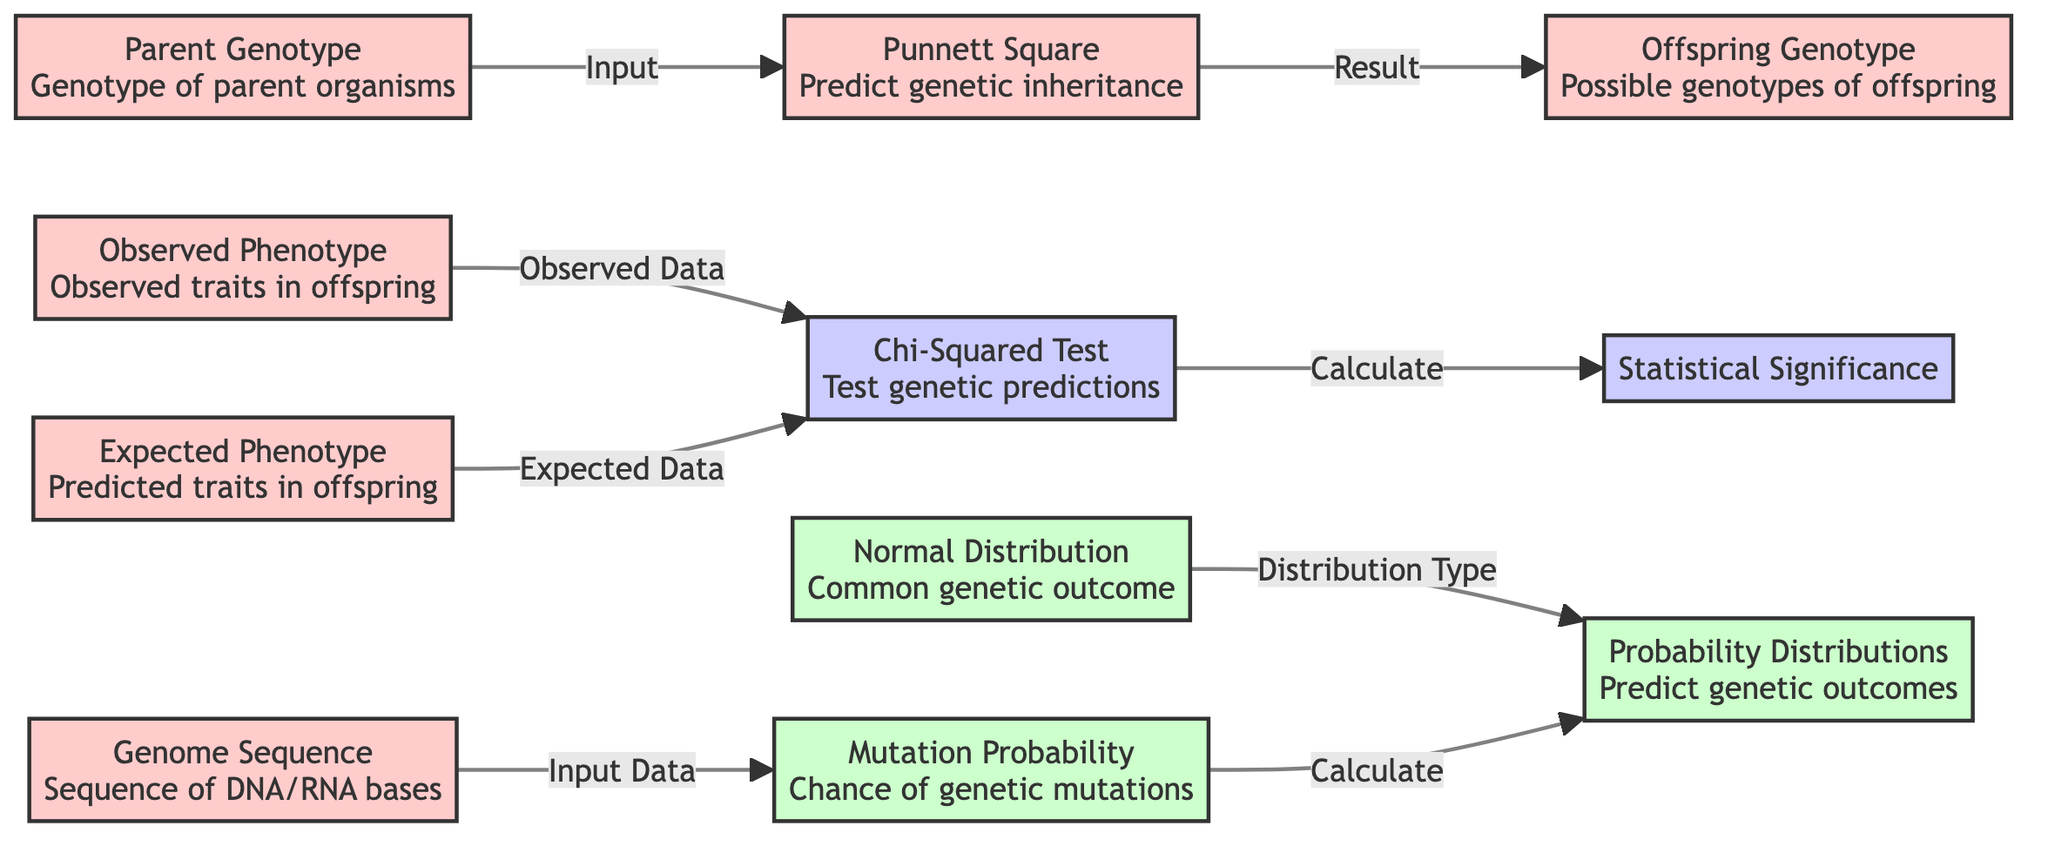What is the output of the Punnett Square? The Punnett Square generates the possible genotypes of offspring based on the input parent genotypes.
Answer: Offspring Genotype What is used as the input for the Chi-Squared Test? The Chi-Squared Test requires both observed and expected phenotypes as inputs to assess genetic predictions.
Answer: Observed Phenotype How many types of probability distributions are shown? The diagram displays one type of probability distribution specifically referred to in the context of genetic outcomes.
Answer: One What follows from the Chi-Squared Test? After conducting the Chi-Squared Test, the next step is to calculate the statistical significance of the observed versus expected phenotypes.
Answer: Statistical Significance Which data is needed to calculate Mutation Probability? To calculate the mutation probability, the genome sequence of the organism must be provided as input data.
Answer: Genome Sequence What relationship is there between Normal Distribution and Probability Distributions? Normal Distribution is one specific type of distribution that is classified under the broader category of probability distributions for predicting genetic outcomes.
Answer: Distribution Type What types of genotypes are determined from the Punnett Square? The Punnett Square determines the possible genotypes of offspring based on the parent genotypes that are fed into it.
Answer: Possible genotypes How does Mutation Probability influence Probability Distributions? Mutation Probability is calculated and subsequently impacts the Probability Distributions by contributing to predicting genetic outcomes related to mutations.
Answer: Calculate Which node references the traits observed in offspring? The node that references the traits that have been observed in the offspring is called Observed Phenotype.
Answer: Observed Phenotype 